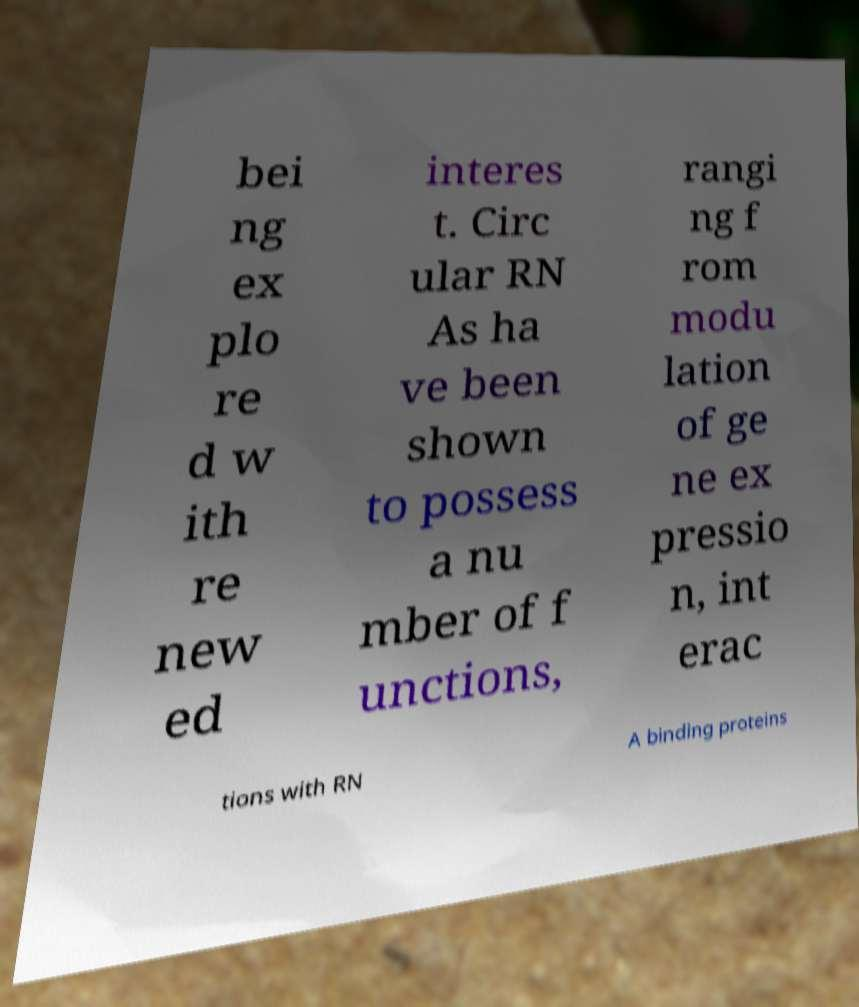I need the written content from this picture converted into text. Can you do that? bei ng ex plo re d w ith re new ed interes t. Circ ular RN As ha ve been shown to possess a nu mber of f unctions, rangi ng f rom modu lation of ge ne ex pressio n, int erac tions with RN A binding proteins 